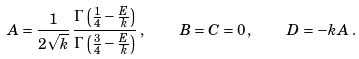<formula> <loc_0><loc_0><loc_500><loc_500>A = \frac { 1 } { 2 \sqrt { k } } \, \frac { \Gamma \left ( \frac { 1 } { 4 } - \frac { E } { k } \right ) } { \Gamma \left ( \frac { 3 } { 4 } - \frac { E } { k } \right ) } \, , \quad B = C = 0 \, , \quad D = - k A \, .</formula> 